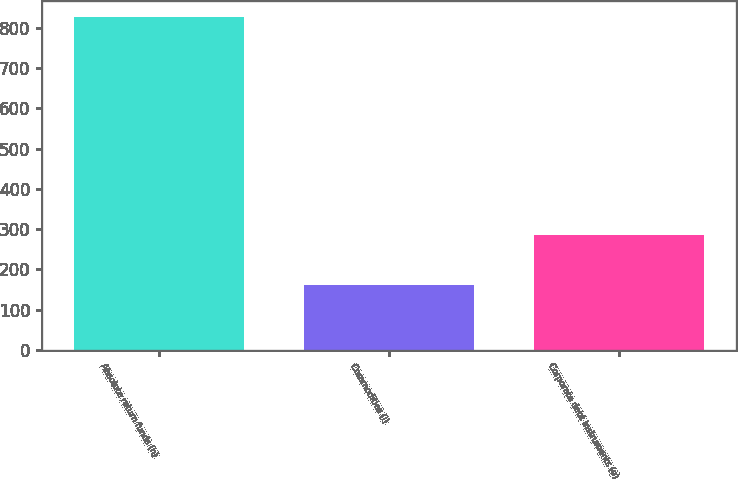Convert chart to OTSL. <chart><loc_0><loc_0><loc_500><loc_500><bar_chart><fcel>Absolute return funds (h)<fcel>Commodities (i)<fcel>Corporate debt instruments (e)<nl><fcel>825<fcel>161<fcel>286<nl></chart> 